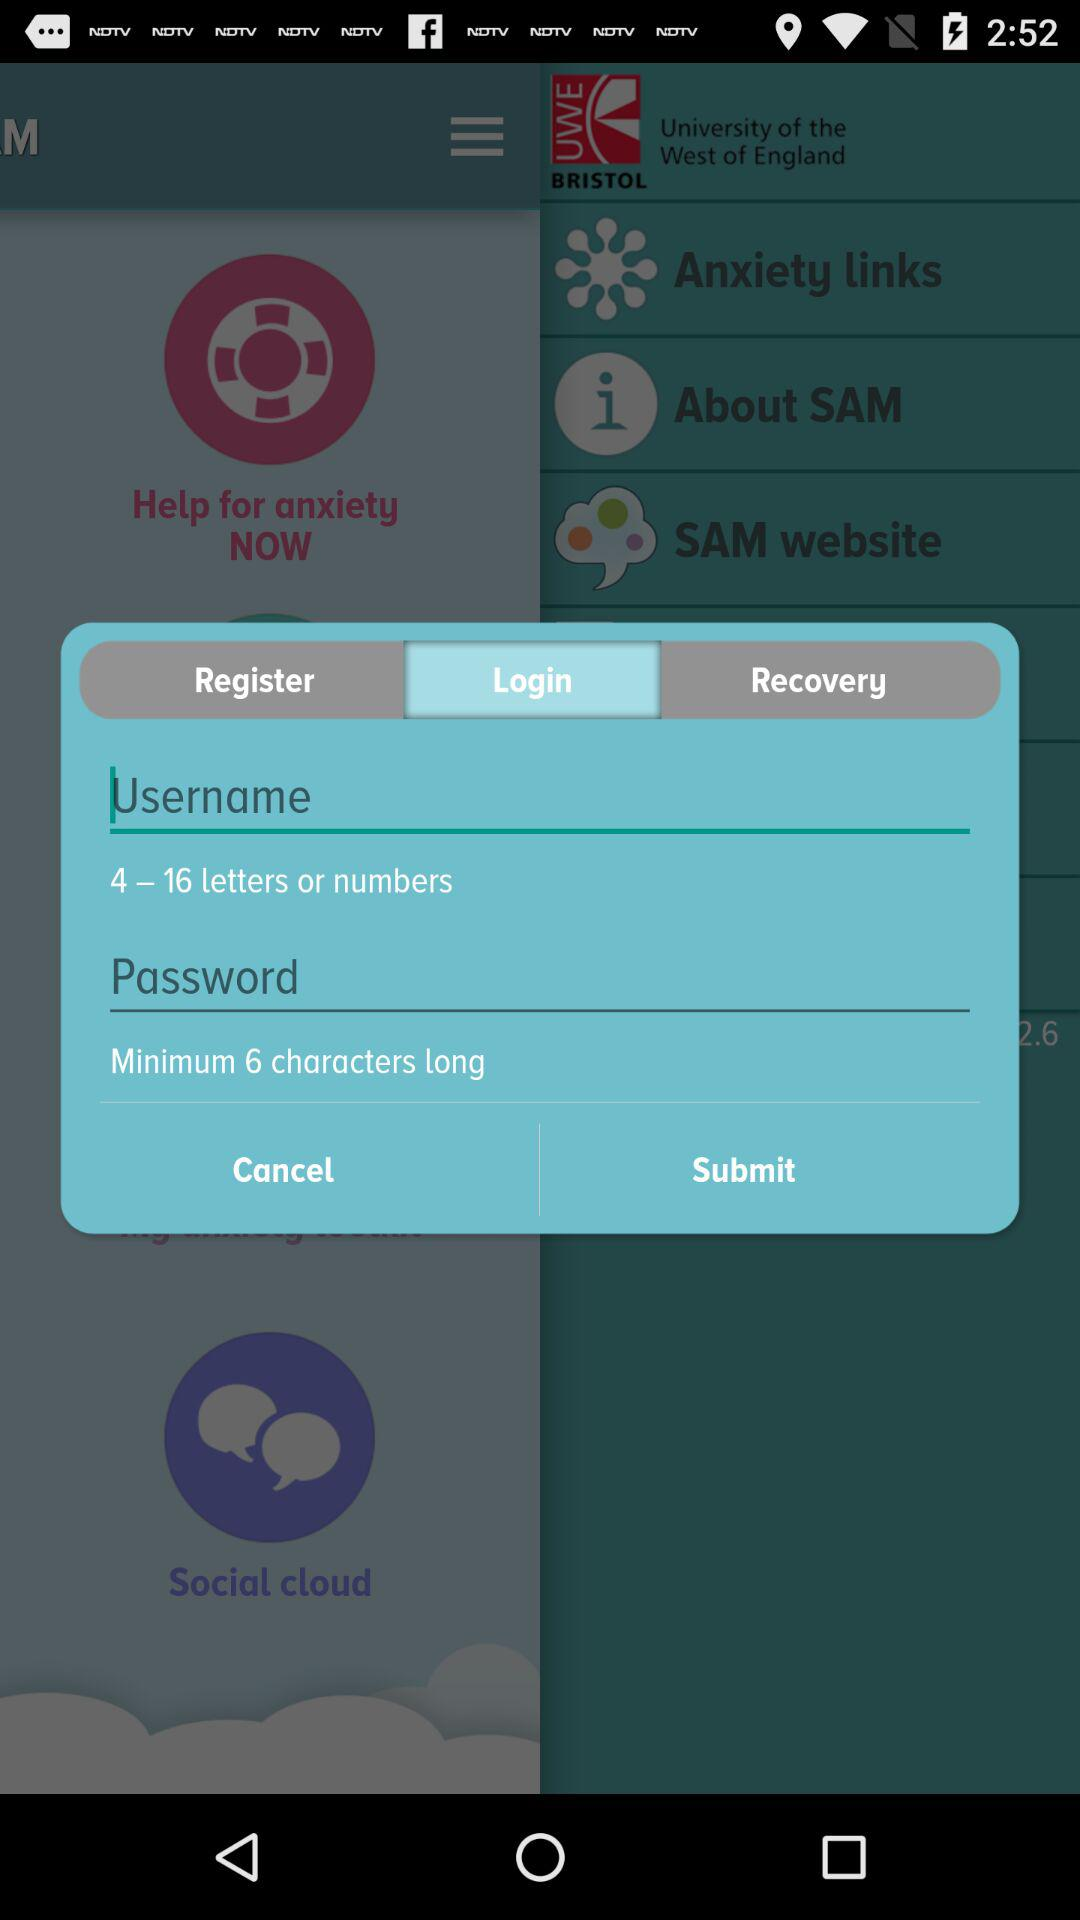Which tab is currently selected? The currently selected tab is "Login". 